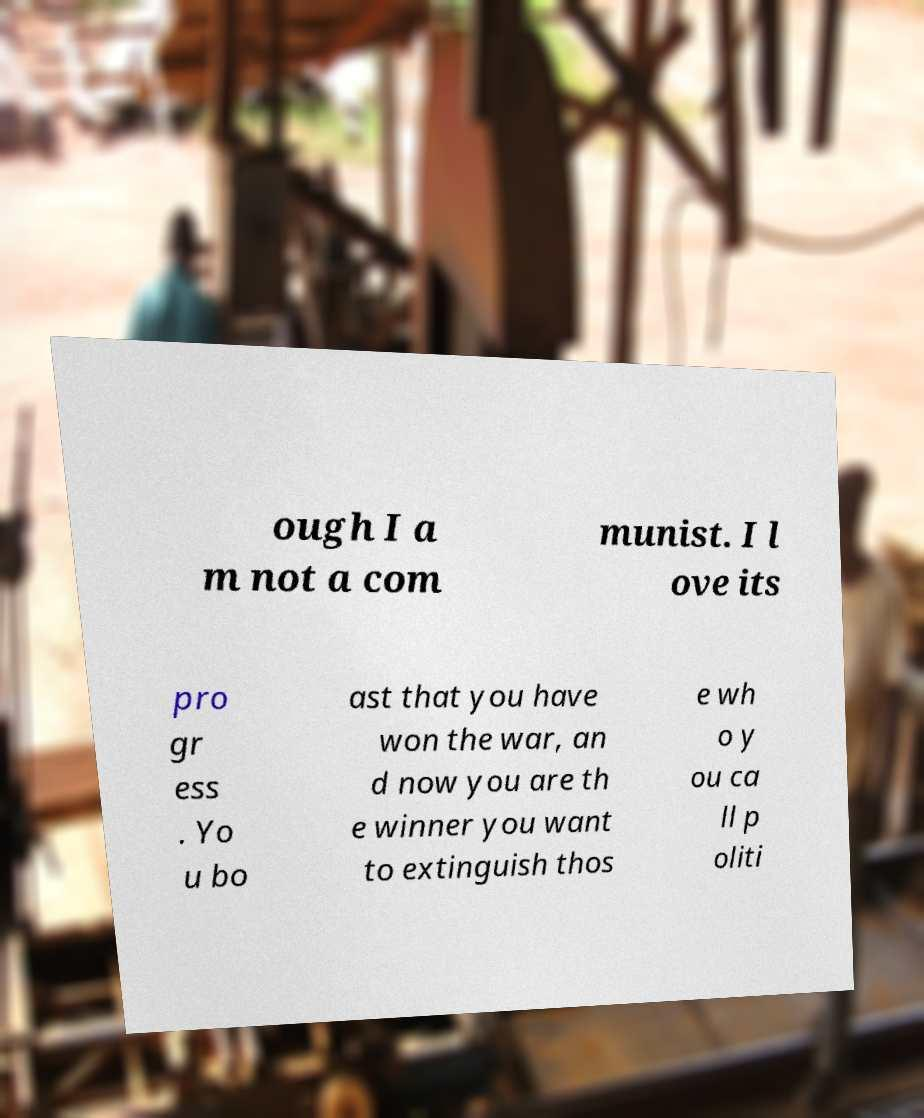I need the written content from this picture converted into text. Can you do that? ough I a m not a com munist. I l ove its pro gr ess . Yo u bo ast that you have won the war, an d now you are th e winner you want to extinguish thos e wh o y ou ca ll p oliti 